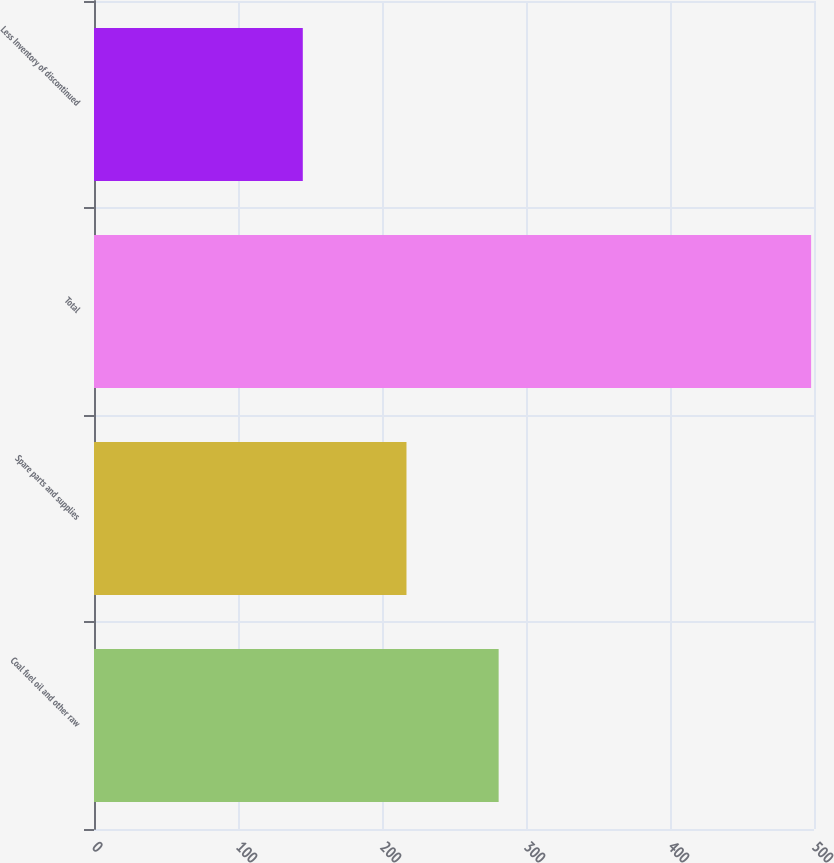<chart> <loc_0><loc_0><loc_500><loc_500><bar_chart><fcel>Coal fuel oil and other raw<fcel>Spare parts and supplies<fcel>Total<fcel>Less Inventory of discontinued<nl><fcel>281<fcel>217<fcel>498<fcel>145<nl></chart> 